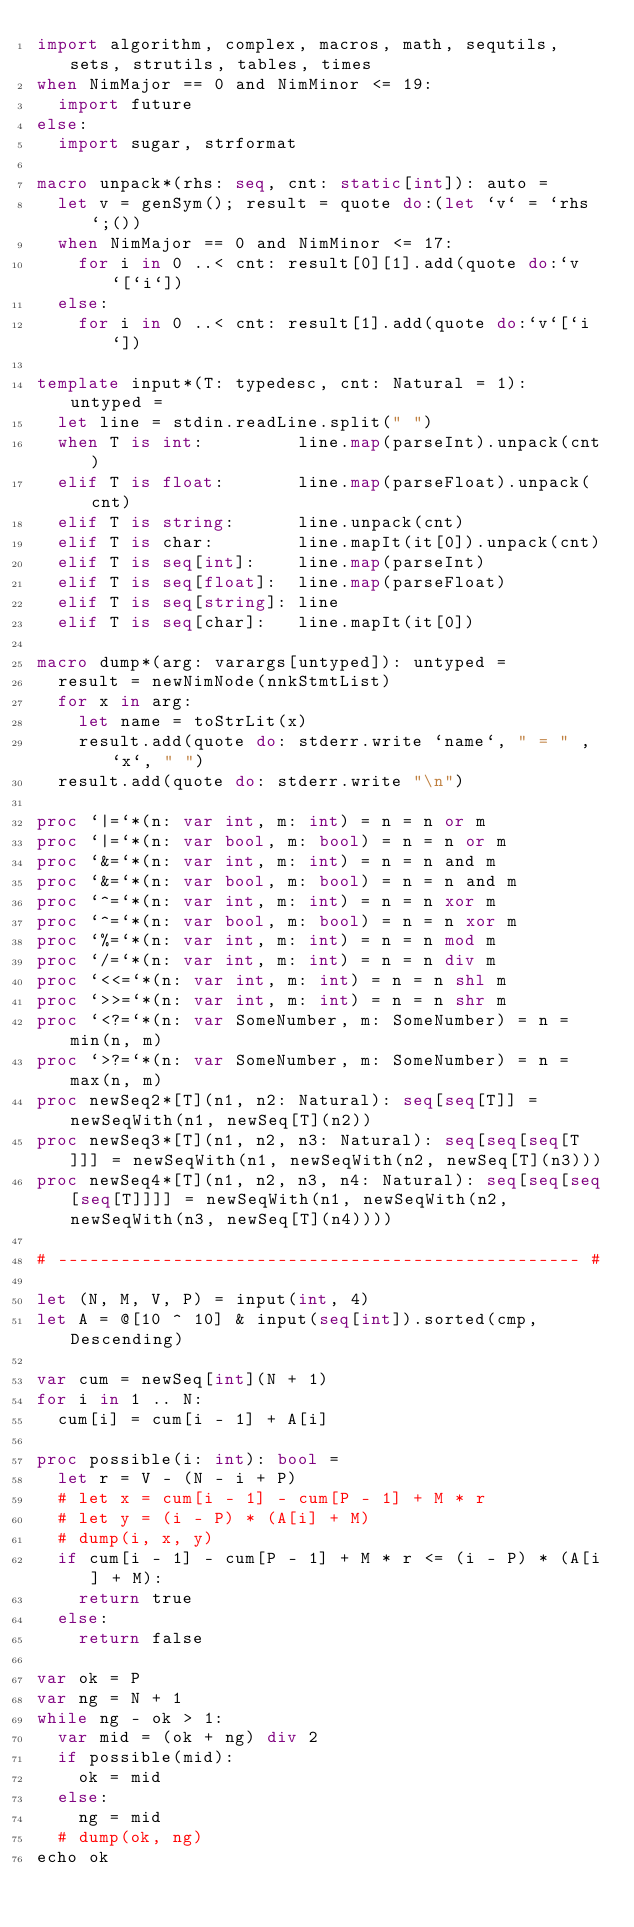Convert code to text. <code><loc_0><loc_0><loc_500><loc_500><_Nim_>import algorithm, complex, macros, math, sequtils, sets, strutils, tables, times
when NimMajor == 0 and NimMinor <= 19:
  import future
else:
  import sugar, strformat

macro unpack*(rhs: seq, cnt: static[int]): auto =
  let v = genSym(); result = quote do:(let `v` = `rhs`;())
  when NimMajor == 0 and NimMinor <= 17:
    for i in 0 ..< cnt: result[0][1].add(quote do:`v`[`i`])
  else:
    for i in 0 ..< cnt: result[1].add(quote do:`v`[`i`])

template input*(T: typedesc, cnt: Natural = 1): untyped =
  let line = stdin.readLine.split(" ")
  when T is int:         line.map(parseInt).unpack(cnt)
  elif T is float:       line.map(parseFloat).unpack(cnt)
  elif T is string:      line.unpack(cnt)
  elif T is char:        line.mapIt(it[0]).unpack(cnt)
  elif T is seq[int]:    line.map(parseInt)
  elif T is seq[float]:  line.map(parseFloat)
  elif T is seq[string]: line
  elif T is seq[char]:   line.mapIt(it[0])

macro dump*(arg: varargs[untyped]): untyped =
  result = newNimNode(nnkStmtList)
  for x in arg:
    let name = toStrLit(x)
    result.add(quote do: stderr.write `name`, " = " , `x`, " ")
  result.add(quote do: stderr.write "\n")

proc `|=`*(n: var int, m: int) = n = n or m
proc `|=`*(n: var bool, m: bool) = n = n or m
proc `&=`*(n: var int, m: int) = n = n and m
proc `&=`*(n: var bool, m: bool) = n = n and m
proc `^=`*(n: var int, m: int) = n = n xor m
proc `^=`*(n: var bool, m: bool) = n = n xor m
proc `%=`*(n: var int, m: int) = n = n mod m
proc `/=`*(n: var int, m: int) = n = n div m
proc `<<=`*(n: var int, m: int) = n = n shl m
proc `>>=`*(n: var int, m: int) = n = n shr m
proc `<?=`*(n: var SomeNumber, m: SomeNumber) = n = min(n, m)
proc `>?=`*(n: var SomeNumber, m: SomeNumber) = n = max(n, m)
proc newSeq2*[T](n1, n2: Natural): seq[seq[T]] = newSeqWith(n1, newSeq[T](n2))
proc newSeq3*[T](n1, n2, n3: Natural): seq[seq[seq[T]]] = newSeqWith(n1, newSeqWith(n2, newSeq[T](n3)))
proc newSeq4*[T](n1, n2, n3, n4: Natural): seq[seq[seq[seq[T]]]] = newSeqWith(n1, newSeqWith(n2, newSeqWith(n3, newSeq[T](n4))))

# -------------------------------------------------- #

let (N, M, V, P) = input(int, 4)
let A = @[10 ^ 10] & input(seq[int]).sorted(cmp, Descending)

var cum = newSeq[int](N + 1)
for i in 1 .. N:
  cum[i] = cum[i - 1] + A[i]

proc possible(i: int): bool =
  let r = V - (N - i + P)
  # let x = cum[i - 1] - cum[P - 1] + M * r
  # let y = (i - P) * (A[i] + M)
  # dump(i, x, y)
  if cum[i - 1] - cum[P - 1] + M * r <= (i - P) * (A[i] + M):
    return true
  else:
    return false

var ok = P
var ng = N + 1
while ng - ok > 1:
  var mid = (ok + ng) div 2
  if possible(mid):
    ok = mid
  else:
    ng = mid
  # dump(ok, ng)
echo ok</code> 